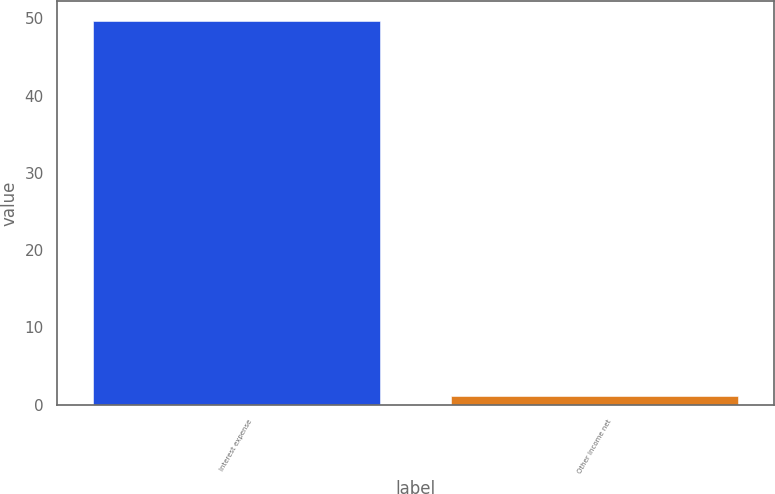<chart> <loc_0><loc_0><loc_500><loc_500><bar_chart><fcel>Interest expense<fcel>Other income net<nl><fcel>49.7<fcel>1.1<nl></chart> 